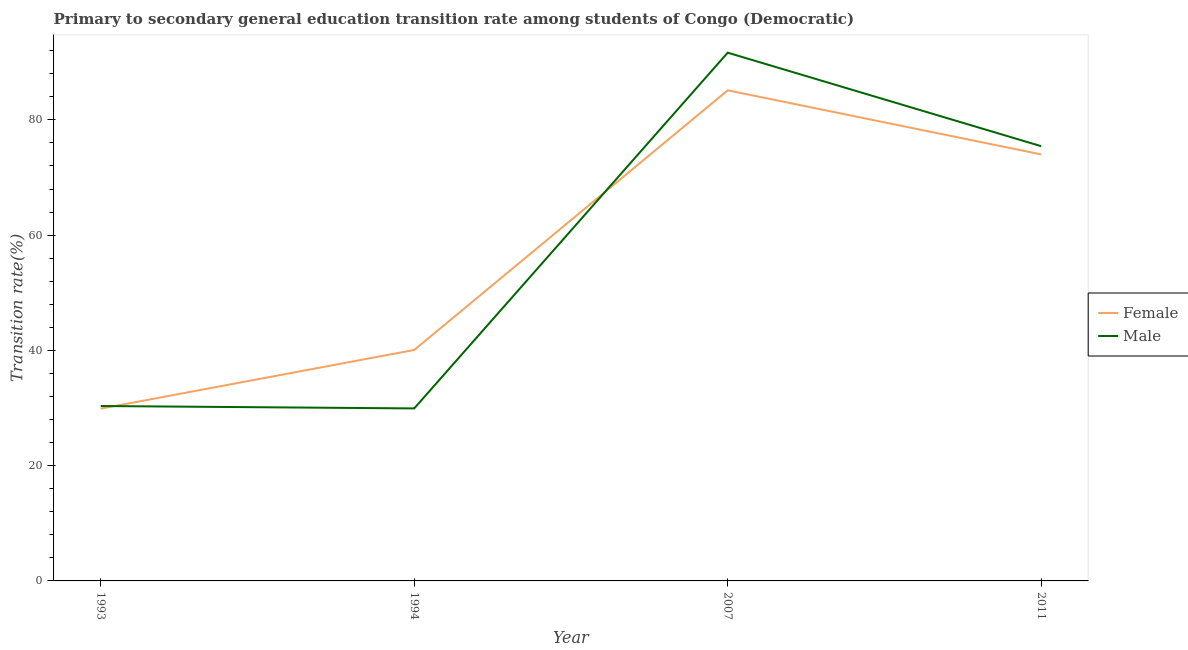How many different coloured lines are there?
Provide a succinct answer. 2. Is the number of lines equal to the number of legend labels?
Make the answer very short. Yes. What is the transition rate among female students in 2007?
Your answer should be compact. 85.13. Across all years, what is the maximum transition rate among male students?
Provide a short and direct response. 91.66. Across all years, what is the minimum transition rate among female students?
Your response must be concise. 29.89. In which year was the transition rate among male students maximum?
Your answer should be very brief. 2007. What is the total transition rate among male students in the graph?
Keep it short and to the point. 227.38. What is the difference between the transition rate among female students in 1994 and that in 2007?
Ensure brevity in your answer.  -45.05. What is the difference between the transition rate among female students in 2011 and the transition rate among male students in 1994?
Keep it short and to the point. 44.08. What is the average transition rate among male students per year?
Give a very brief answer. 56.85. In the year 2011, what is the difference between the transition rate among female students and transition rate among male students?
Give a very brief answer. -1.43. What is the ratio of the transition rate among female students in 1994 to that in 2007?
Keep it short and to the point. 0.47. What is the difference between the highest and the second highest transition rate among female students?
Your response must be concise. 11.12. What is the difference between the highest and the lowest transition rate among male students?
Your answer should be compact. 61.73. Is the transition rate among female students strictly less than the transition rate among male students over the years?
Provide a short and direct response. No. How many lines are there?
Provide a succinct answer. 2. How many years are there in the graph?
Provide a short and direct response. 4. What is the difference between two consecutive major ticks on the Y-axis?
Offer a very short reply. 20. Are the values on the major ticks of Y-axis written in scientific E-notation?
Make the answer very short. No. How are the legend labels stacked?
Provide a succinct answer. Vertical. What is the title of the graph?
Offer a very short reply. Primary to secondary general education transition rate among students of Congo (Democratic). Does "Non-resident workers" appear as one of the legend labels in the graph?
Give a very brief answer. No. What is the label or title of the X-axis?
Ensure brevity in your answer.  Year. What is the label or title of the Y-axis?
Your answer should be very brief. Transition rate(%). What is the Transition rate(%) in Female in 1993?
Give a very brief answer. 29.89. What is the Transition rate(%) in Male in 1993?
Provide a short and direct response. 30.35. What is the Transition rate(%) in Female in 1994?
Your answer should be very brief. 40.08. What is the Transition rate(%) in Male in 1994?
Provide a succinct answer. 29.93. What is the Transition rate(%) of Female in 2007?
Offer a very short reply. 85.13. What is the Transition rate(%) of Male in 2007?
Give a very brief answer. 91.66. What is the Transition rate(%) of Female in 2011?
Make the answer very short. 74.01. What is the Transition rate(%) in Male in 2011?
Offer a very short reply. 75.44. Across all years, what is the maximum Transition rate(%) in Female?
Offer a very short reply. 85.13. Across all years, what is the maximum Transition rate(%) of Male?
Your response must be concise. 91.66. Across all years, what is the minimum Transition rate(%) of Female?
Your answer should be very brief. 29.89. Across all years, what is the minimum Transition rate(%) in Male?
Provide a short and direct response. 29.93. What is the total Transition rate(%) of Female in the graph?
Provide a succinct answer. 229.11. What is the total Transition rate(%) in Male in the graph?
Make the answer very short. 227.38. What is the difference between the Transition rate(%) in Female in 1993 and that in 1994?
Your answer should be compact. -10.18. What is the difference between the Transition rate(%) in Male in 1993 and that in 1994?
Make the answer very short. 0.42. What is the difference between the Transition rate(%) of Female in 1993 and that in 2007?
Give a very brief answer. -55.24. What is the difference between the Transition rate(%) in Male in 1993 and that in 2007?
Provide a short and direct response. -61.31. What is the difference between the Transition rate(%) in Female in 1993 and that in 2011?
Offer a terse response. -44.12. What is the difference between the Transition rate(%) in Male in 1993 and that in 2011?
Make the answer very short. -45.09. What is the difference between the Transition rate(%) of Female in 1994 and that in 2007?
Keep it short and to the point. -45.05. What is the difference between the Transition rate(%) in Male in 1994 and that in 2007?
Provide a succinct answer. -61.73. What is the difference between the Transition rate(%) of Female in 1994 and that in 2011?
Ensure brevity in your answer.  -33.93. What is the difference between the Transition rate(%) of Male in 1994 and that in 2011?
Your response must be concise. -45.5. What is the difference between the Transition rate(%) in Female in 2007 and that in 2011?
Make the answer very short. 11.12. What is the difference between the Transition rate(%) of Male in 2007 and that in 2011?
Provide a short and direct response. 16.23. What is the difference between the Transition rate(%) of Female in 1993 and the Transition rate(%) of Male in 1994?
Keep it short and to the point. -0.04. What is the difference between the Transition rate(%) of Female in 1993 and the Transition rate(%) of Male in 2007?
Offer a very short reply. -61.77. What is the difference between the Transition rate(%) of Female in 1993 and the Transition rate(%) of Male in 2011?
Your response must be concise. -45.54. What is the difference between the Transition rate(%) of Female in 1994 and the Transition rate(%) of Male in 2007?
Make the answer very short. -51.59. What is the difference between the Transition rate(%) in Female in 1994 and the Transition rate(%) in Male in 2011?
Offer a very short reply. -35.36. What is the difference between the Transition rate(%) in Female in 2007 and the Transition rate(%) in Male in 2011?
Give a very brief answer. 9.69. What is the average Transition rate(%) of Female per year?
Your response must be concise. 57.28. What is the average Transition rate(%) of Male per year?
Give a very brief answer. 56.85. In the year 1993, what is the difference between the Transition rate(%) of Female and Transition rate(%) of Male?
Your response must be concise. -0.46. In the year 1994, what is the difference between the Transition rate(%) in Female and Transition rate(%) in Male?
Ensure brevity in your answer.  10.14. In the year 2007, what is the difference between the Transition rate(%) of Female and Transition rate(%) of Male?
Your answer should be compact. -6.53. In the year 2011, what is the difference between the Transition rate(%) of Female and Transition rate(%) of Male?
Provide a short and direct response. -1.43. What is the ratio of the Transition rate(%) of Female in 1993 to that in 1994?
Give a very brief answer. 0.75. What is the ratio of the Transition rate(%) of Female in 1993 to that in 2007?
Offer a very short reply. 0.35. What is the ratio of the Transition rate(%) in Male in 1993 to that in 2007?
Offer a terse response. 0.33. What is the ratio of the Transition rate(%) of Female in 1993 to that in 2011?
Your answer should be compact. 0.4. What is the ratio of the Transition rate(%) in Male in 1993 to that in 2011?
Give a very brief answer. 0.4. What is the ratio of the Transition rate(%) in Female in 1994 to that in 2007?
Make the answer very short. 0.47. What is the ratio of the Transition rate(%) of Male in 1994 to that in 2007?
Your response must be concise. 0.33. What is the ratio of the Transition rate(%) in Female in 1994 to that in 2011?
Keep it short and to the point. 0.54. What is the ratio of the Transition rate(%) of Male in 1994 to that in 2011?
Make the answer very short. 0.4. What is the ratio of the Transition rate(%) in Female in 2007 to that in 2011?
Your answer should be compact. 1.15. What is the ratio of the Transition rate(%) of Male in 2007 to that in 2011?
Provide a short and direct response. 1.22. What is the difference between the highest and the second highest Transition rate(%) in Female?
Give a very brief answer. 11.12. What is the difference between the highest and the second highest Transition rate(%) of Male?
Make the answer very short. 16.23. What is the difference between the highest and the lowest Transition rate(%) in Female?
Offer a terse response. 55.24. What is the difference between the highest and the lowest Transition rate(%) in Male?
Your answer should be compact. 61.73. 